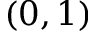<formula> <loc_0><loc_0><loc_500><loc_500>( 0 , 1 )</formula> 